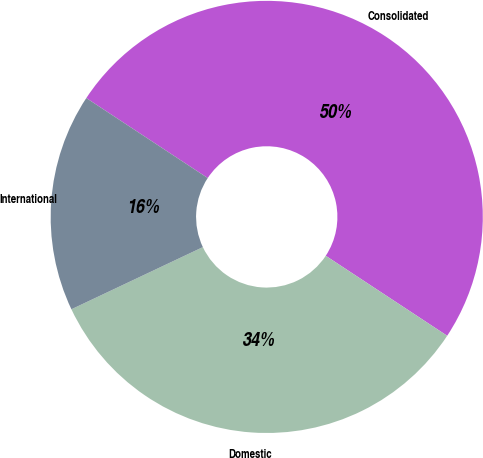Convert chart. <chart><loc_0><loc_0><loc_500><loc_500><pie_chart><fcel>Consolidated<fcel>Domestic<fcel>International<nl><fcel>50.0%<fcel>33.7%<fcel>16.3%<nl></chart> 